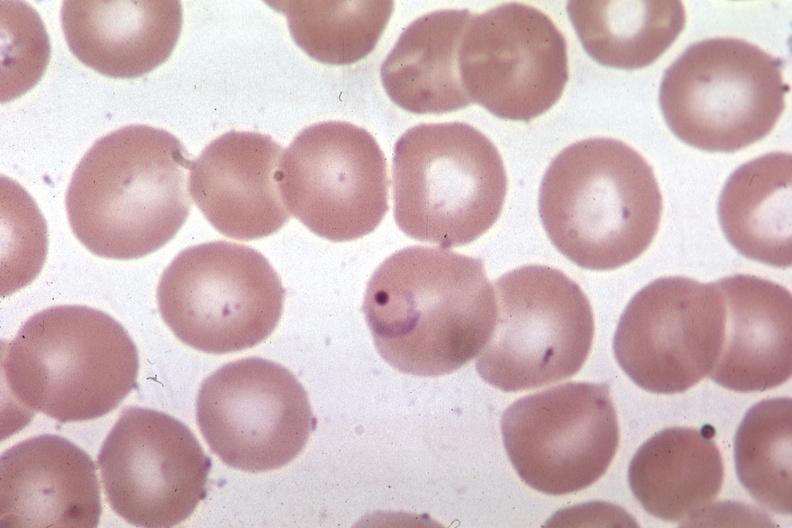what is present?
Answer the question using a single word or phrase. Hematologic 